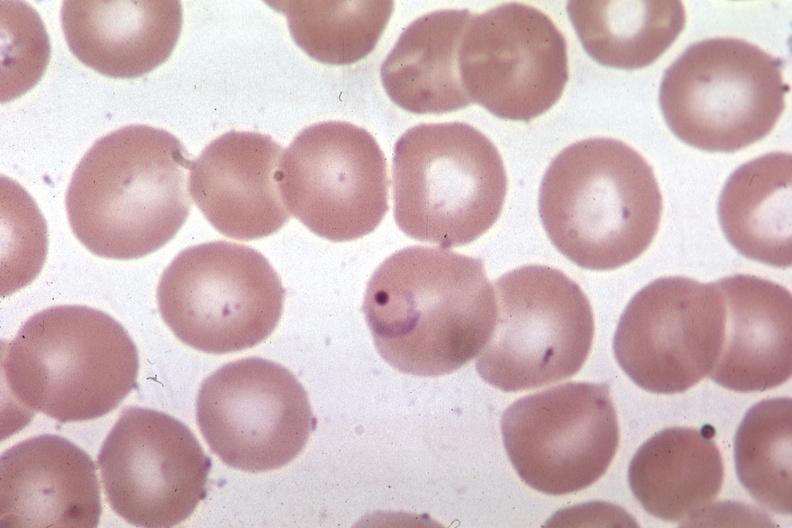what is present?
Answer the question using a single word or phrase. Hematologic 